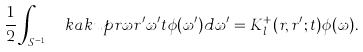<formula> <loc_0><loc_0><loc_500><loc_500>\frac { 1 } 2 \int _ { S ^ { m - 1 } } \ k a k u p { r \omega } { r ^ { \prime } \omega ^ { \prime } } { t } \phi ( \omega ^ { \prime } ) d \omega ^ { \prime } = K _ { l } ^ { + } ( r , r ^ { \prime } ; t ) \phi ( \omega ) .</formula> 